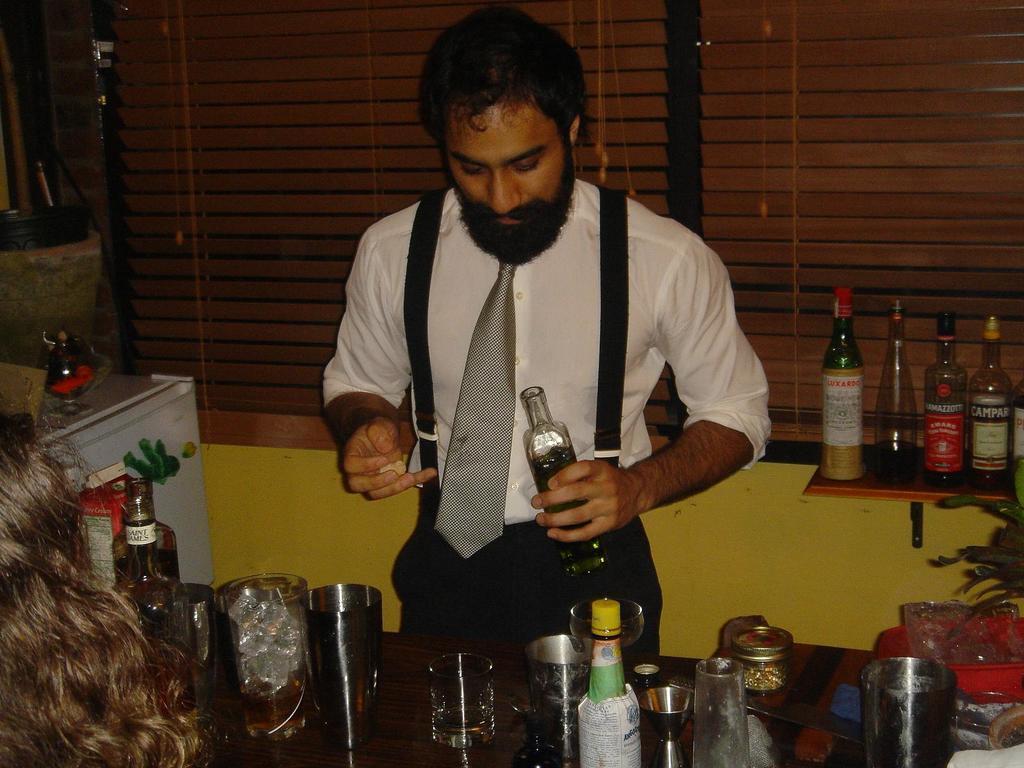How would you summarize this image in a sentence or two? In this picture we can see a man standing and holding a bottle, there is a table in front of him, we can see glasses and bottles present on the table, in the background there are window blinds, on the right side there are four bottles and a plant, we can see another person´s hair at the left bottom. 